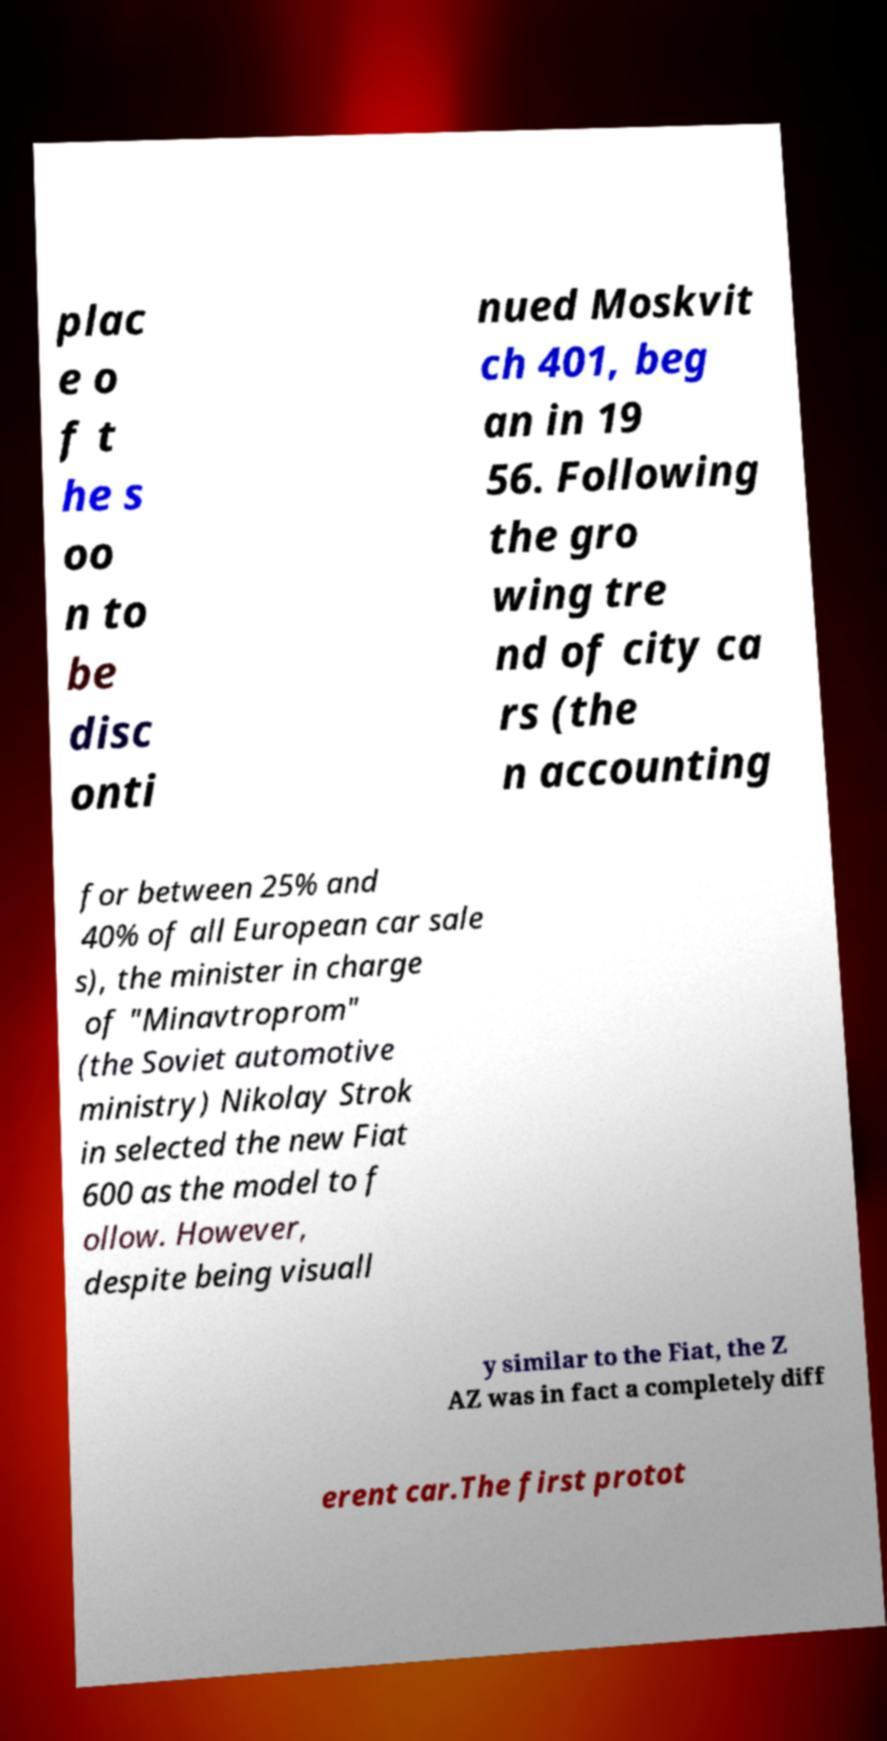What messages or text are displayed in this image? I need them in a readable, typed format. plac e o f t he s oo n to be disc onti nued Moskvit ch 401, beg an in 19 56. Following the gro wing tre nd of city ca rs (the n accounting for between 25% and 40% of all European car sale s), the minister in charge of "Minavtroprom" (the Soviet automotive ministry) Nikolay Strok in selected the new Fiat 600 as the model to f ollow. However, despite being visuall y similar to the Fiat, the Z AZ was in fact a completely diff erent car.The first protot 